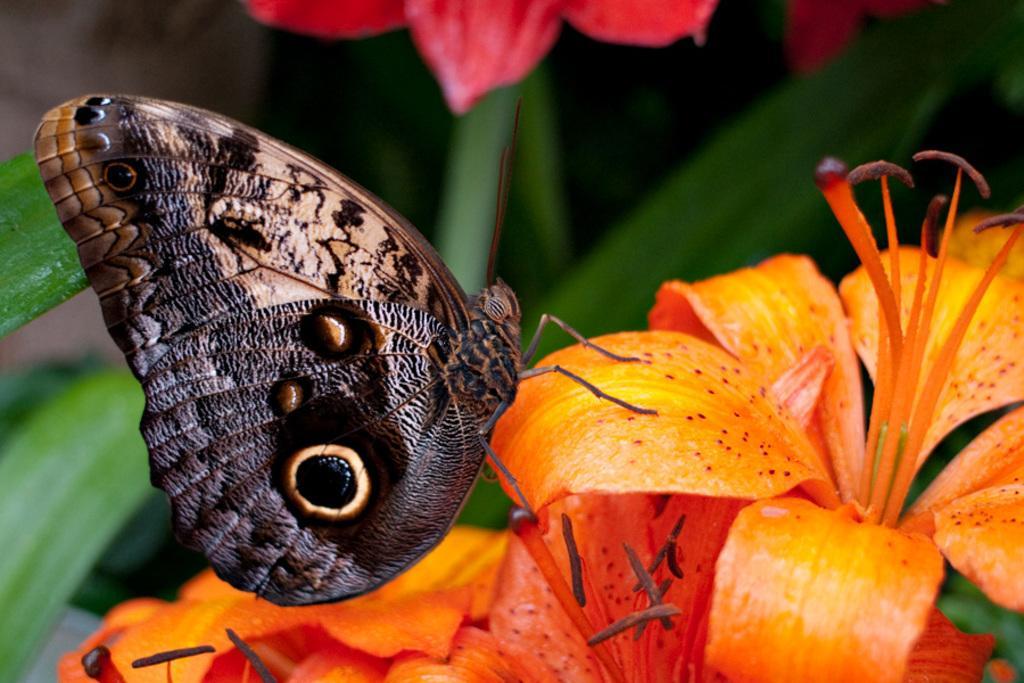Describe this image in one or two sentences. In the image we can see the butterfly and flowers, yellow and orange in color. Here we can see leaves and the background is slightly blurred.  